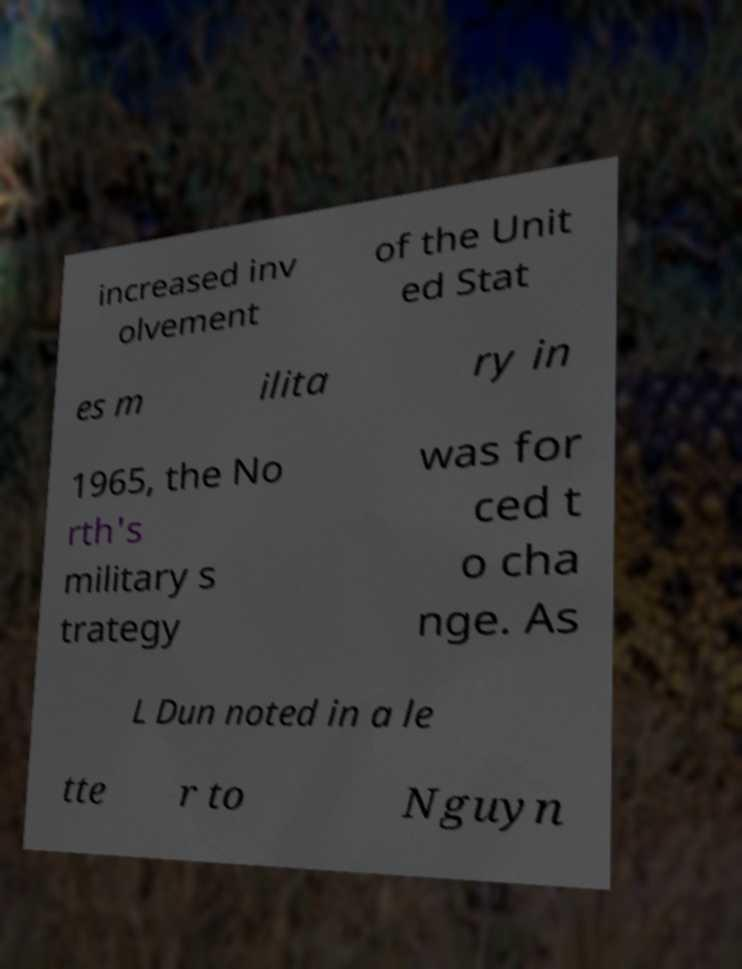Could you assist in decoding the text presented in this image and type it out clearly? increased inv olvement of the Unit ed Stat es m ilita ry in 1965, the No rth's military s trategy was for ced t o cha nge. As L Dun noted in a le tte r to Nguyn 